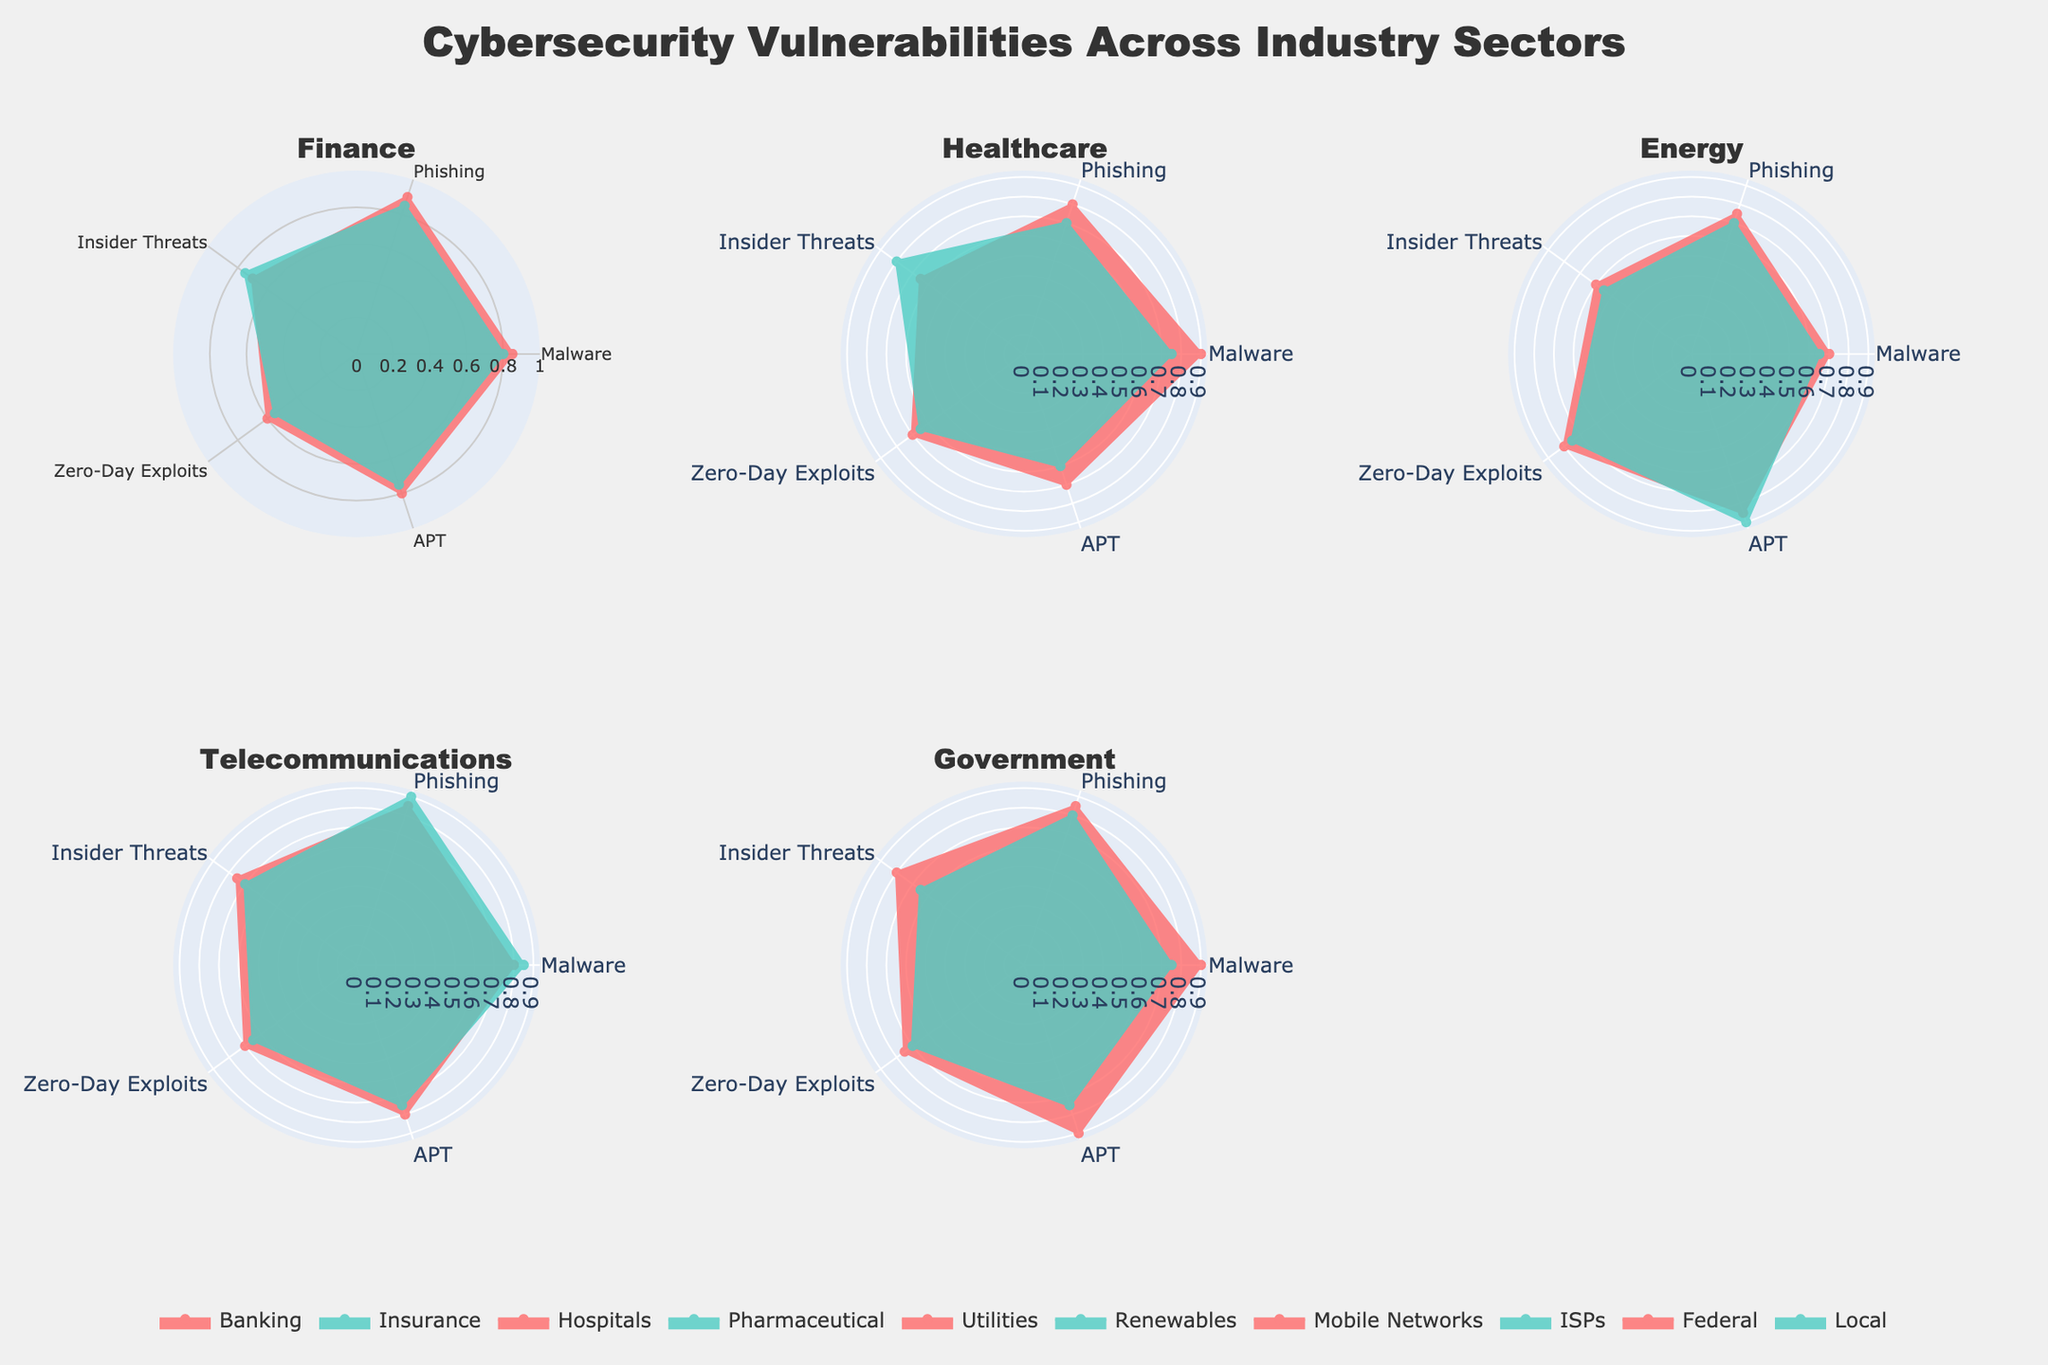What title is shown on the plot? The title is found at the top center of the figure, often in larger, bold font. This figure's title is "Cybersecurity Vulnerabilities Across Industry Sectors" as indicated in the layout configuration.
Answer: Cybersecurity Vulnerabilities Across Industry Sectors Which sectors fall under the Government industry in the plot? Referring to the subplots, Government has two sectors named Federal and Local, depicted in their respective subplot area.
Answer: Federal and Local Which sector has the highest value for Zero-Day Exploits within the Energy industry? In the subplot for the Energy industry, Utilities and Renewables sectors are compared for Zero-Day Exploits. Utilities (0.8) has a higher value than Renewables (0.75).
Answer: Utilities Compare Malware vulnerability between Banking and Hospitals sectors. Which one has the higher value? By visually comparing the Malware metric in the polar plots for Banking (0.85) and Hospitals (0.9), Hospitals has a slightly higher value.
Answer: Hospitals Which industry sector shows the highest susceptibility to APT threats and what is the value? By examining all subplots for the APT values, Federal (Government) sector has the highest susceptibility with a value of 0.9.
Answer: Federal, 0.9 Out of all sectors in Telecommunications, which has the higher value for Phishing attacks? Comparing Phishing values for Mobile Networks (0.85) and ISPs (0.9) in the Telecommunications subplot, ISPs have the higher value.
Answer: ISPs How does the value of Insider Threats in the Pharmaceutical sector compare to that in the Federal sector? Inspecting the values in their respective subplots; Pharmaceutical sector (Healthcare) is 0.8, and Federal sector (Government) is 0.8, showing they are equal.
Answer: They are equal Identify the sector in Finance that has lesser vulnerability in Zero-Day Exploits. Within the Finance subplot, Banking (0.6) and Insurance (0.55), Insurance has lesser vulnerability in Zero-Day Exploits.
Answer: Insurance What is the average value of Malware susceptibility across all sectors in the Healthcare industry? Adding the Malware values for Hospitals (0.9) and Pharmaceutical (0.75) and dividing by 2 gives (0.9 + 0.75) / 2 = 0.825.
Answer: 0.825 